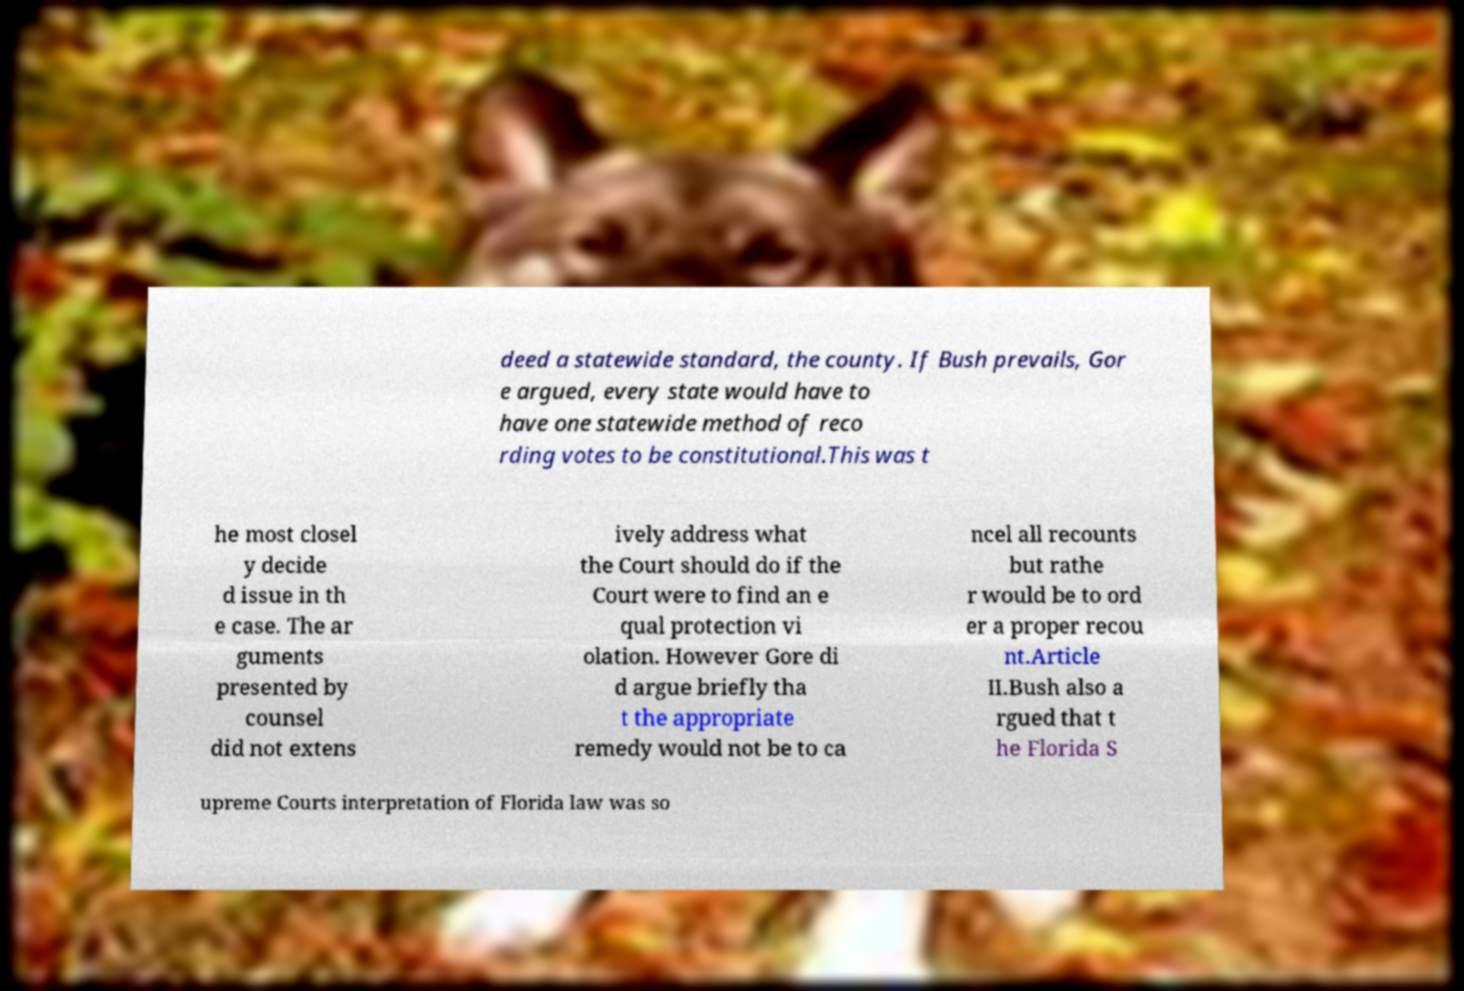Could you extract and type out the text from this image? deed a statewide standard, the county. If Bush prevails, Gor e argued, every state would have to have one statewide method of reco rding votes to be constitutional.This was t he most closel y decide d issue in th e case. The ar guments presented by counsel did not extens ively address what the Court should do if the Court were to find an e qual protection vi olation. However Gore di d argue briefly tha t the appropriate remedy would not be to ca ncel all recounts but rathe r would be to ord er a proper recou nt.Article II.Bush also a rgued that t he Florida S upreme Courts interpretation of Florida law was so 